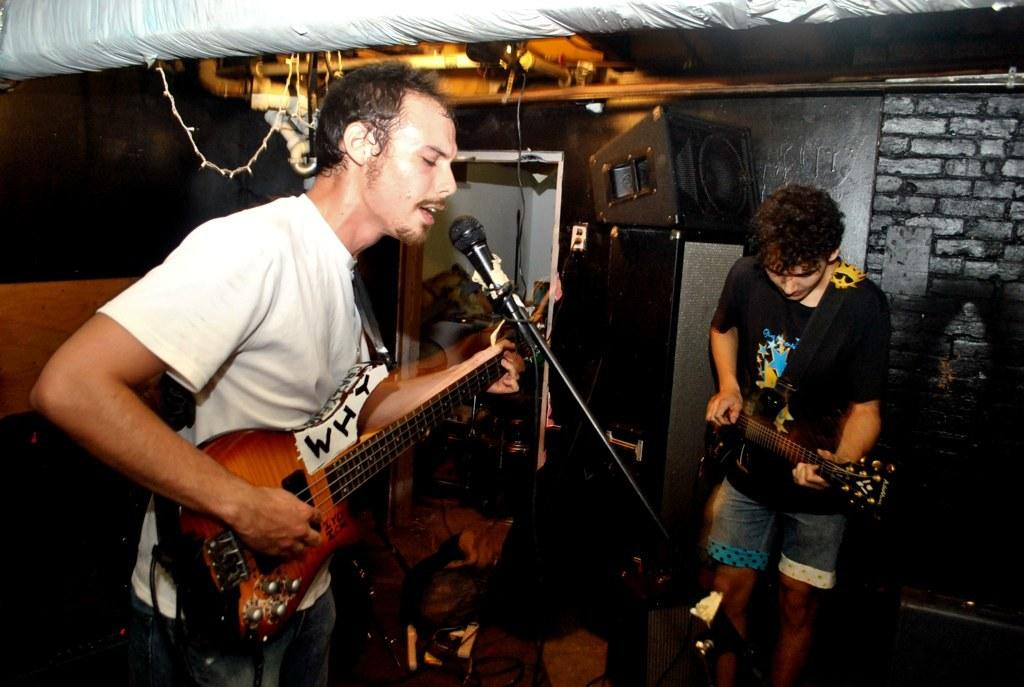What is the man in the image doing with the guitar? The man is playing a guitar in the image. What else is the man doing while playing the guitar? The man is singing in the image. How is the man's voice being amplified while singing? The man is using a microphone while singing. Are there any other musicians in the image? Yes, there is another man playing a guitar in the image. What type of teeth can be seen in the image? There are no teeth visible in the image, as it features people playing guitars and singing. 